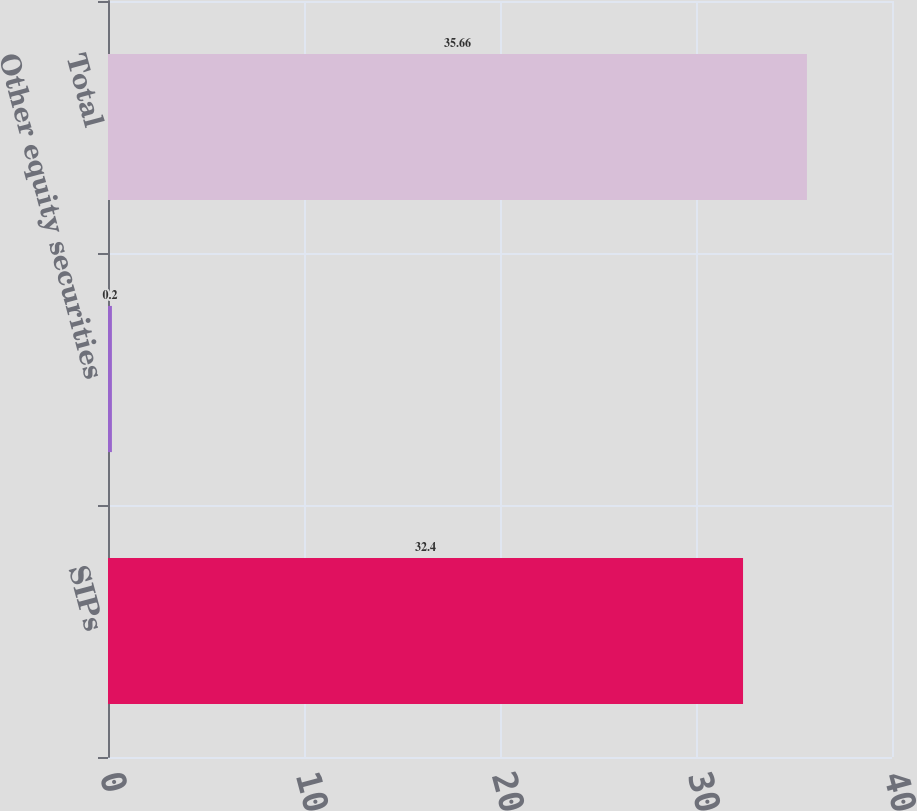<chart> <loc_0><loc_0><loc_500><loc_500><bar_chart><fcel>SIPs<fcel>Other equity securities<fcel>Total<nl><fcel>32.4<fcel>0.2<fcel>35.66<nl></chart> 